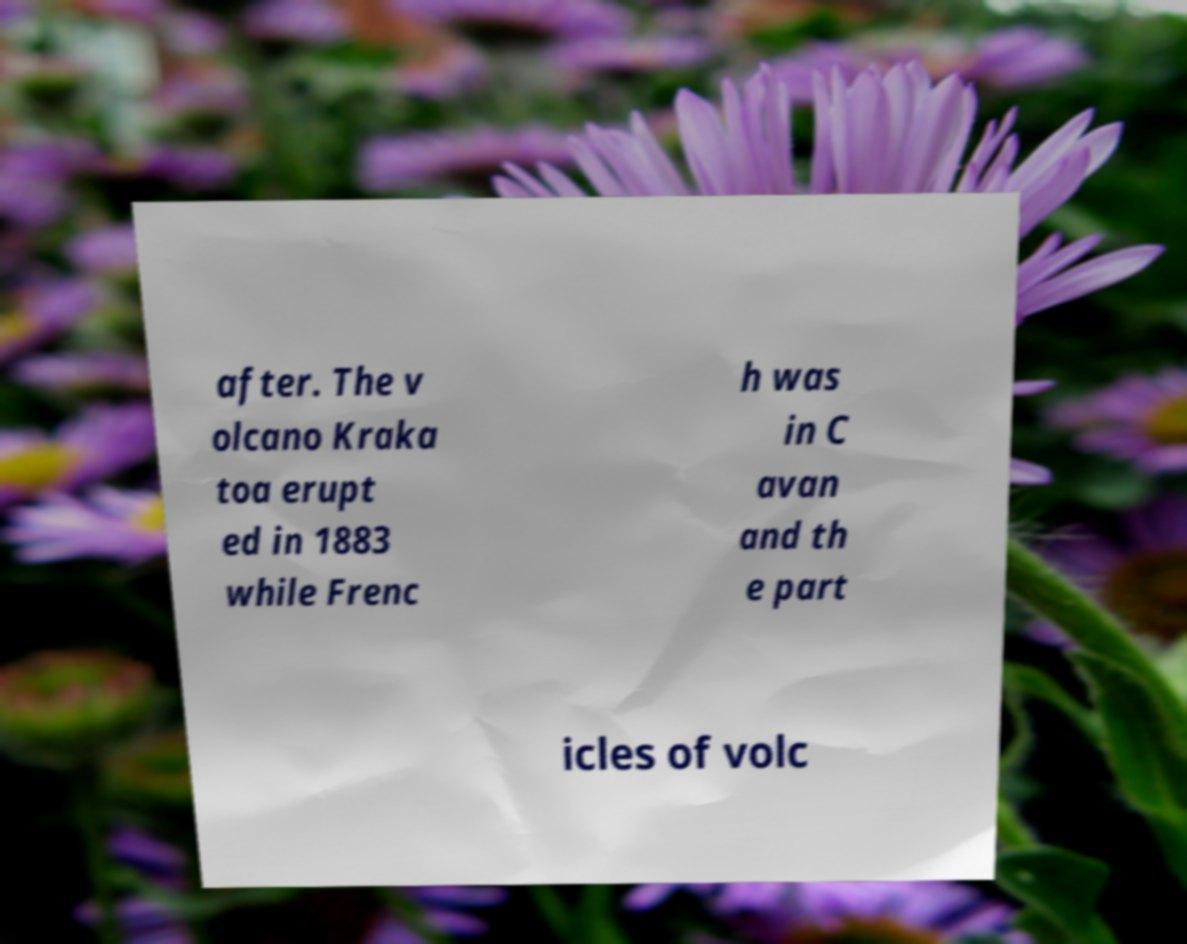Can you accurately transcribe the text from the provided image for me? after. The v olcano Kraka toa erupt ed in 1883 while Frenc h was in C avan and th e part icles of volc 